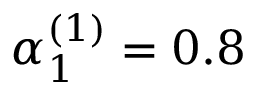<formula> <loc_0><loc_0><loc_500><loc_500>\alpha _ { 1 } ^ { ( 1 ) } = 0 . 8</formula> 